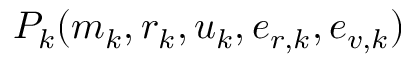Convert formula to latex. <formula><loc_0><loc_0><loc_500><loc_500>P _ { k } ( m _ { k } , r _ { k } , u _ { k } , e _ { r , k } , e _ { v , k } )</formula> 